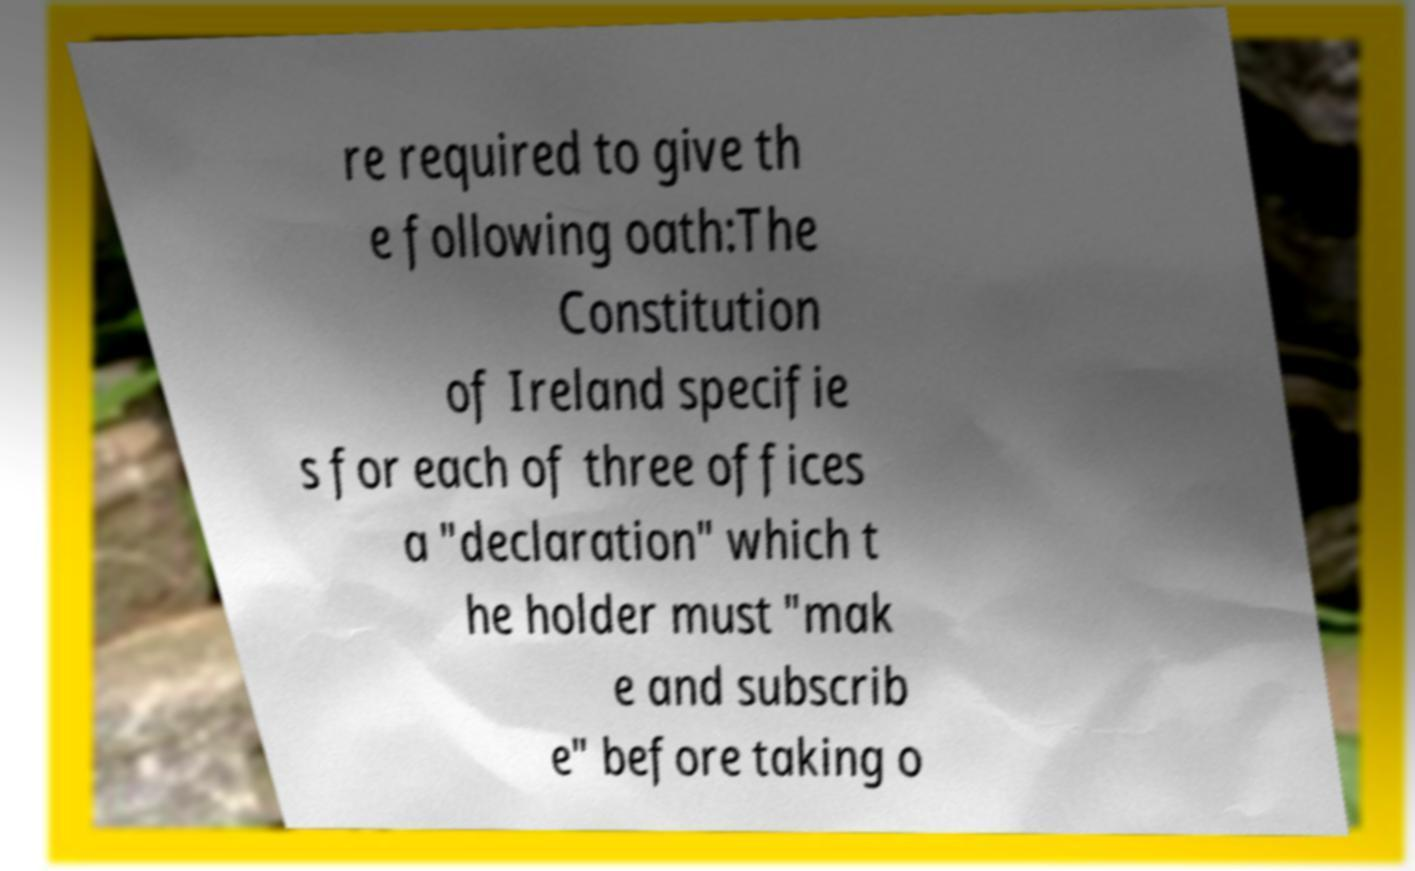Could you extract and type out the text from this image? re required to give th e following oath:The Constitution of Ireland specifie s for each of three offices a "declaration" which t he holder must "mak e and subscrib e" before taking o 